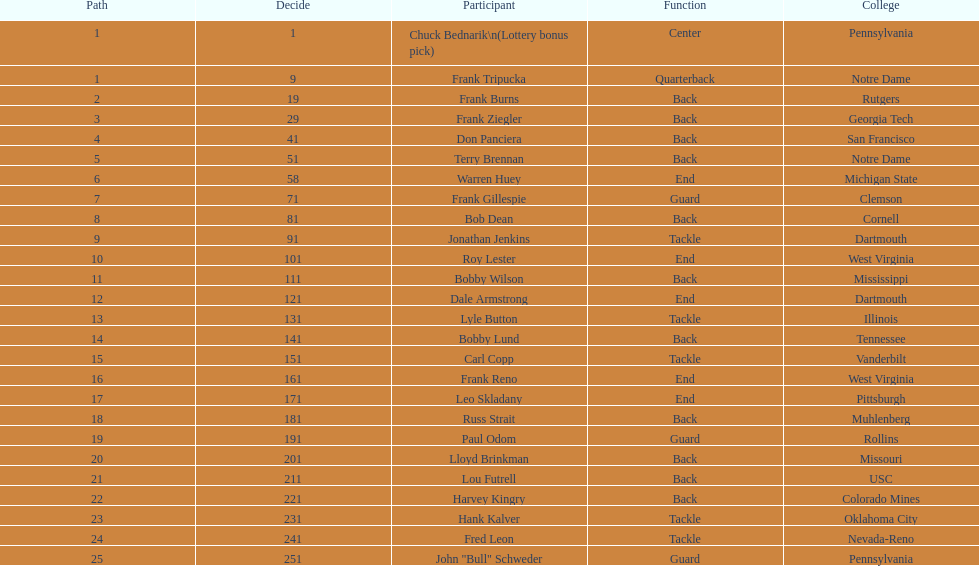Who was selected following roy lester? Bobby Wilson. 